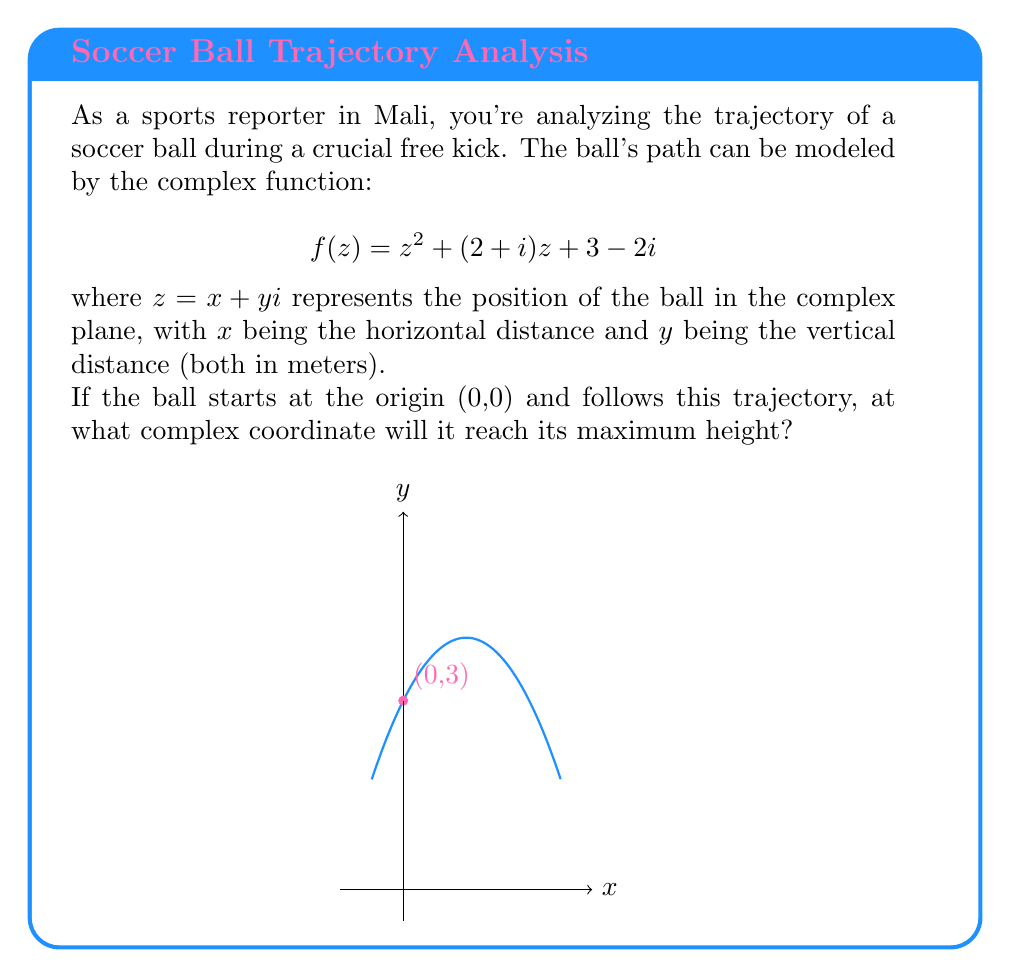Could you help me with this problem? Let's approach this step-by-step:

1) To find the maximum height, we need to find the vertex of the parabola described by the imaginary part of $f(z)$.

2) First, let's separate the real and imaginary parts of $f(z)$:
   $f(z) = (x^2 - y^2 + 2x + 3) + (2xy + x - 2)i$

3) The imaginary part represents the vertical displacement (height):
   $y = 2xy + x - 2$

4) For a fixed $x$, this is a linear function in $y$. The maximum height will occur when $x$ is at its critical point.

5) To find this, we need to express $y$ in terms of $x$ alone. We can do this by solving the equation $y = -x^2 + 2x + 3$, which represents the path of the ball.

6) Substituting this into the imaginary part:
   $-x^2 + 2x + 3 = 2x(-x^2 + 2x + 3) + x - 2$

7) Simplifying:
   $-x^2 + 2x + 3 = -2x^3 + 4x^2 + 6x + x - 2$
   $2x^3 - 5x^2 - 5x + 5 = 0$

8) This cubic equation has one real root at $x = 1$. (You can verify this by substitution or using the rational root theorem)

9) When $x = 1$, $y = -1^2 + 2(1) + 3 = 4$

Therefore, the ball reaches its maximum height at the complex coordinate $1 + 4i$.
Answer: $1 + 4i$ 